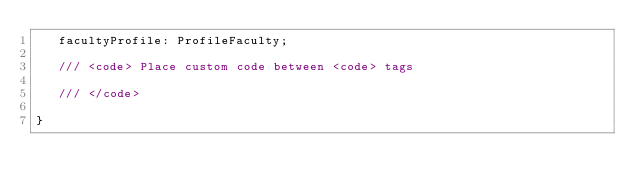Convert code to text. <code><loc_0><loc_0><loc_500><loc_500><_TypeScript_>   facultyProfile: ProfileFaculty;

   /// <code> Place custom code between <code> tags
   
   /// </code>

}

</code> 